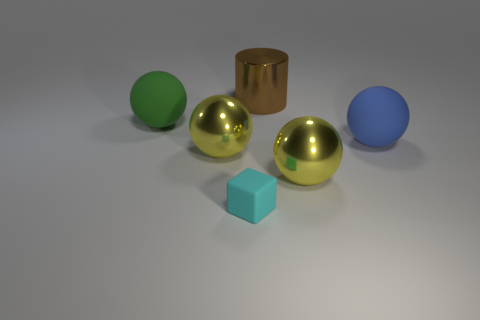Subtract all blue spheres. How many spheres are left? 3 Subtract all yellow balls. How many balls are left? 2 Add 3 brown metallic cylinders. How many objects exist? 9 Subtract 0 red balls. How many objects are left? 6 Subtract all balls. How many objects are left? 2 Subtract 1 cubes. How many cubes are left? 0 Subtract all red blocks. Subtract all green balls. How many blocks are left? 1 Subtract all brown blocks. How many blue balls are left? 1 Subtract all large green objects. Subtract all tiny matte cubes. How many objects are left? 4 Add 2 large matte things. How many large matte things are left? 4 